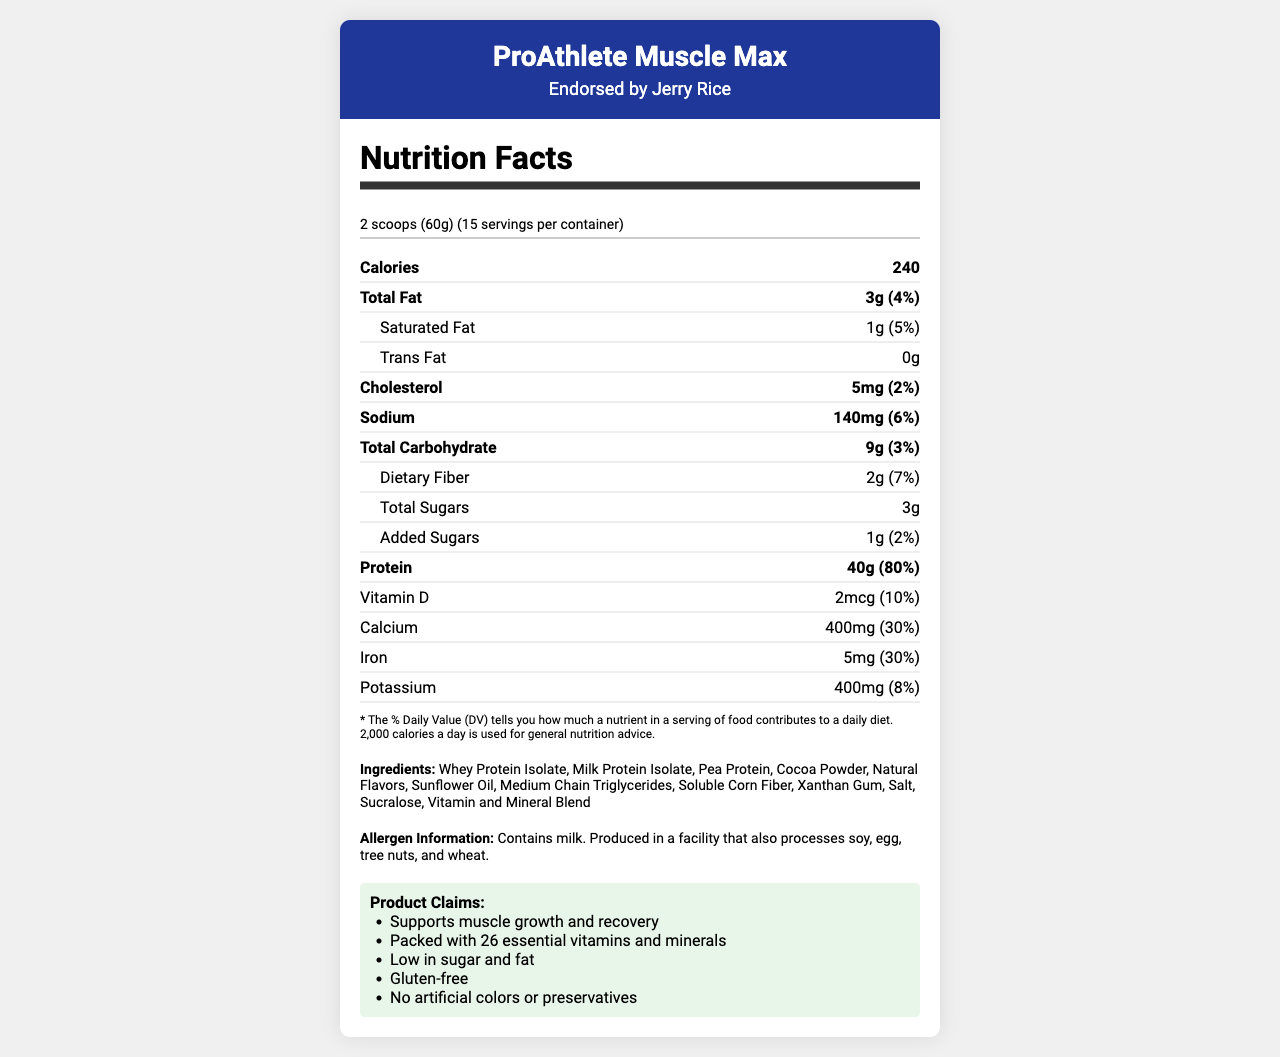what is the serving size? The document details that the serving size of the product is 2 scoops, which amounts to 60 grams.
Answer: 2 scoops (60g) how many servings per container are there? The document specifies that there are 15 servings per container.
Answer: 15 what is the amount of protein per serving? The document states that each serving contains 40 grams of protein.
Answer: 40g how much saturated fat is in one serving? The nutrition facts label shows that there is 1 gram of saturated fat per serving.
Answer: 1g what is the amount of dietary fiber in one serving? According to the document, each serving contains 2 grams of dietary fiber.
Answer: 2g what is the total fat daily value percentage per serving? The document shows that the total fat daily value percentage in one serving is 4%.
Answer: 4% which of the following is NOT an ingredient in ProAthlete Muscle Max? A. Whey Protein Concentrate B. Pea Protein C. Sunflower Oil D. Xanthan Gum The ingredient list in the document includes Pea Protein, Sunflower Oil, and Xanthan Gum, but not Whey Protein Concentrate.
Answer: A. Whey Protein Concentrate how much cholesterol is in one serving? A. 2mg B. 5mg C. 10mg D. 15mg The document shows that each serving contains 5mg of cholesterol.
Answer: B. 5mg is this product gluten-free? One of the product claims in the document is that the product is gluten-free.
Answer: Yes describe the main idea of the document The document outlines the nutritional content of the product, ingredient list, and highlights various product claims endorsed by Jerry Rice.
Answer: The document provides the nutritional information for "ProAthlete Muscle Max," a high-protein meal replacement shake endorsed by former NFL player Jerry Rice. It includes details on serving size, calories, fats, cholesterol, carbohydrates, sugars, proteins, vitamins, and minerals, along with a list of ingredients, allergen information, and product claims. how much Vitamin C does one serving provide? The document specifies that one serving contains 45mg of Vitamin C.
Answer: 45mg how many grams of added sugars are in one serving? The document shows that one serving contains 1 gram of added sugars.
Answer: 1g does the product have any Trans Fat? The nutrition facts label indicates that the product contains 0 grams of Trans Fat.
Answer: No does this product contain soy? Although the allergen info states that the product is produced in a facility that processes soy, it does not confirm whether soy is an ingredient in the product.
Answer: Cannot be determined what is the primary source of protein in the product? The first ingredient listed, which is usually the primary source, is Whey Protein Isolate, confirming it as the primary source of protein.
Answer: Whey Protein Isolate 